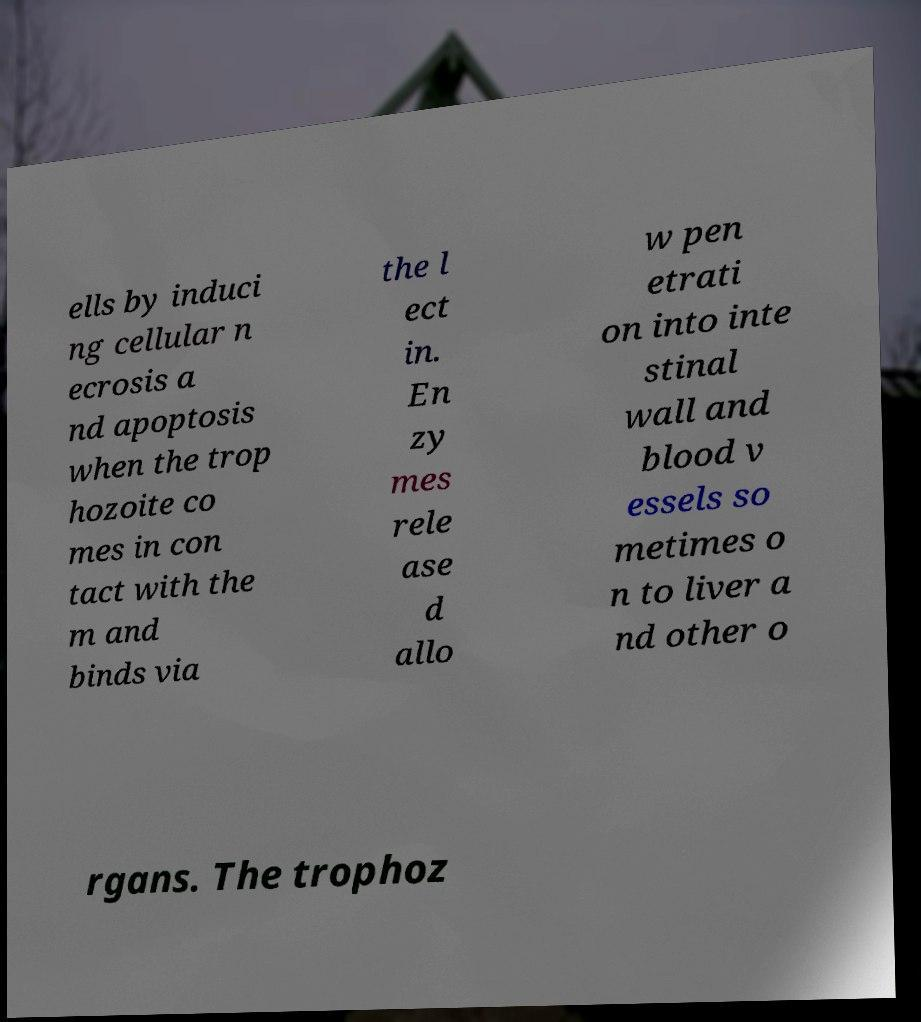Could you assist in decoding the text presented in this image and type it out clearly? ells by induci ng cellular n ecrosis a nd apoptosis when the trop hozoite co mes in con tact with the m and binds via the l ect in. En zy mes rele ase d allo w pen etrati on into inte stinal wall and blood v essels so metimes o n to liver a nd other o rgans. The trophoz 